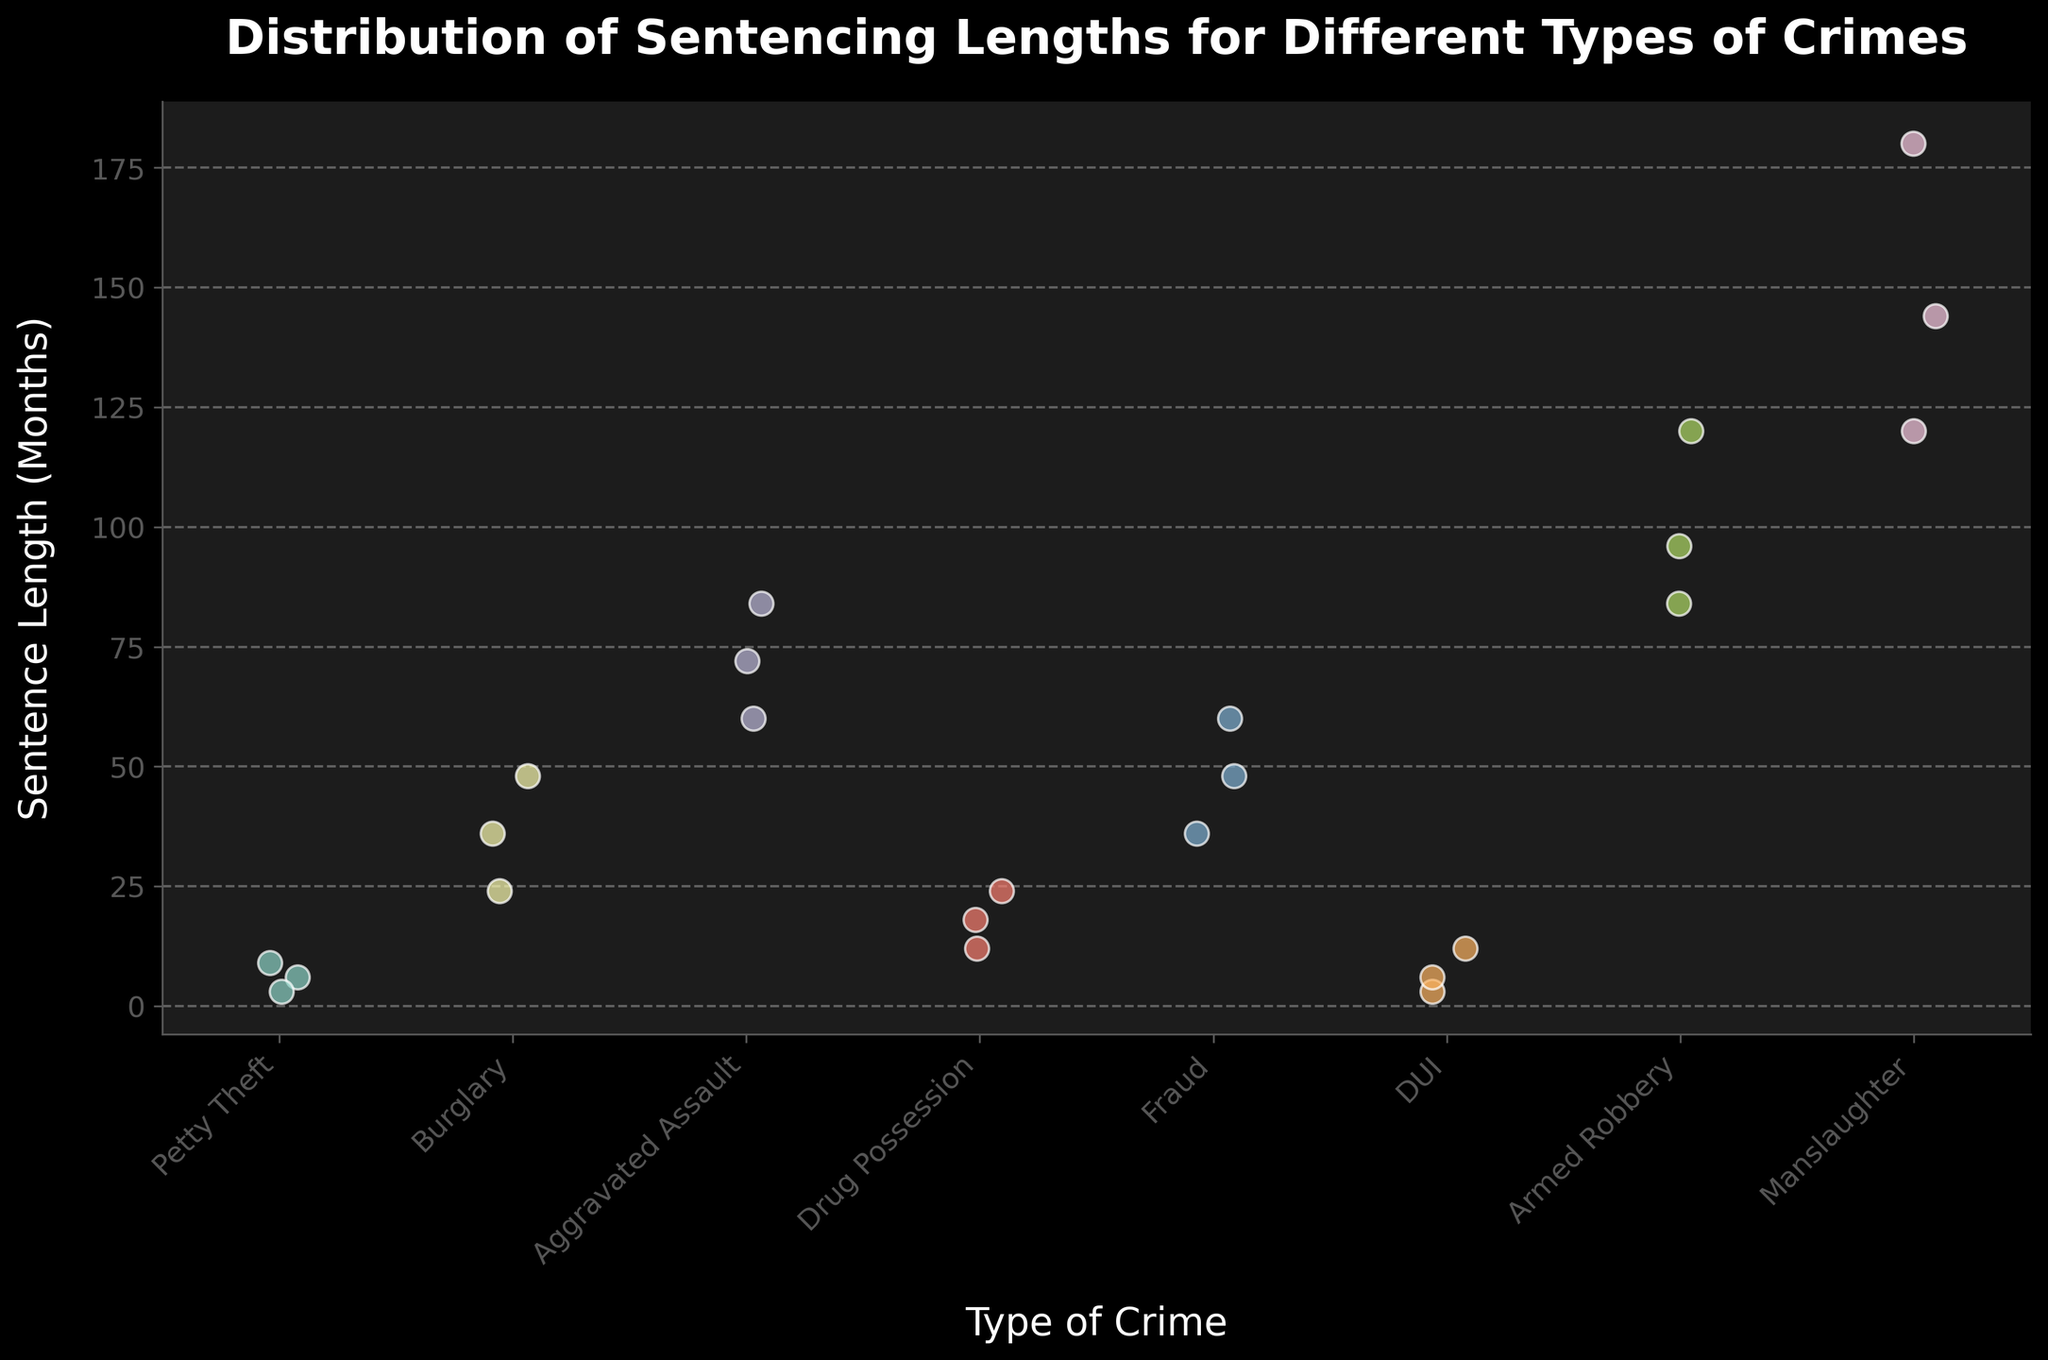How many types of crimes are shown in the figure? Count the number of unique crime types on the x-axis.
Answer: 7 Which type of crime has the highest maximum sentence length represented? Compare the sentence lengths across all types of crimes and identify the one with the highest maximum value.
Answer: Manslaughter What's the median sentence length for burglary? List the sentence lengths for burglary (24, 36, 48), sort them, and find the middle value.
Answer: 36 Between petty theft and DUI, which has a higher average sentence length? Calculate the average sentence length for each type: Petty Theft (6+3+9)/3 = 6, DUI (3+6+12)/3 = 7, and compare the averages.
Answer: DUI How many data points represent sentences for armed robbery? Count the number of individual dots (data points) in the strip plot for armed robbery.
Answer: 3 Which type of crime shows the most variation in sentence lengths? Observe the spread (range) of the sentence lengths for each crime type and identify the one with the widest spread.
Answer: Manslaughter Are there any crimes where all sentence lengths are equal? Review each crime category to see if any have data points that are exactly the same.
Answer: No What is the difference between the longest and shortest sentence for drug possession? Subtract the shortest sentence length (12 months) from the longest sentence length (24 months) for drug possession.
Answer: 12 months Which crime category has the highest minimum sentence length? Compare the minimum values of sentence lengths for each crime category and identify which one is the highest.
Answer: Aggravated Assault Based on the plot, can you conclude that more severe crimes receive longer sentences? Compare the sentence lengths for more severe crimes (e.g., manslaughter, armed robbery) with less severe crimes (e.g., petty theft, DUI) to determine if there's a general trend.
Answer: Yes 